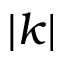<formula> <loc_0><loc_0><loc_500><loc_500>| k |</formula> 